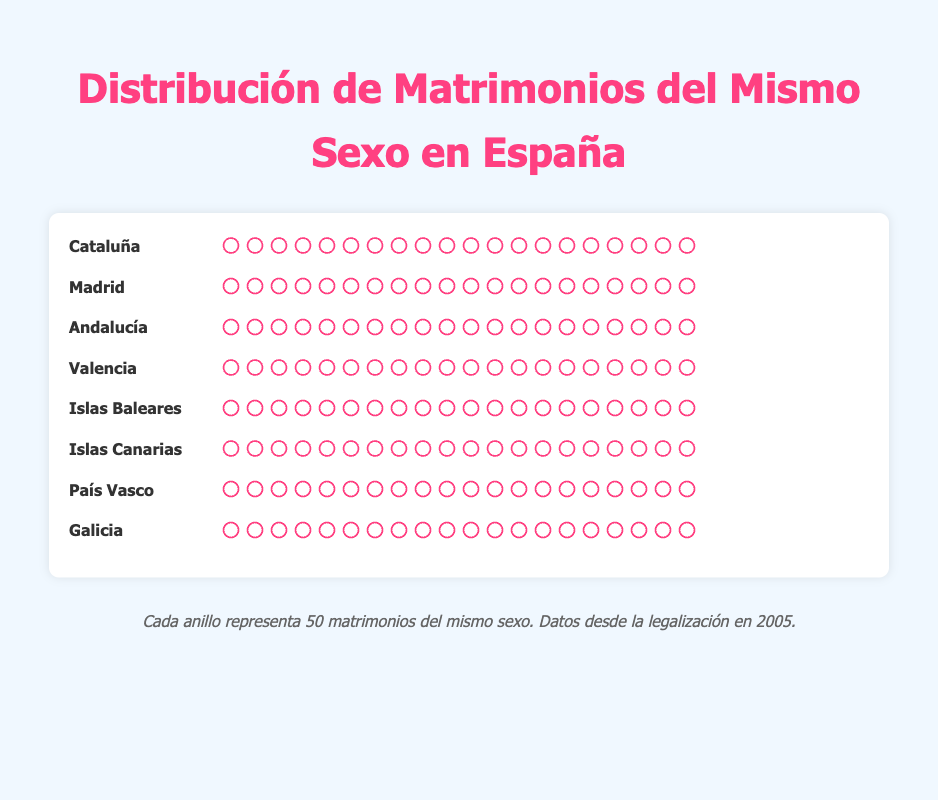Which region has the highest number of same-sex marriages? By looking at the figure, Catalonia has the most icons, which represent the number of marriages.
Answer: Catalonia How many same-sex marriages are there in Madrid? By counting the number of icons in the Madrid row, each representing 525 marriages, we see there are 20 icons. Multiplying 525 by 20 gives the total.
Answer: 10500 Which region has fewer same-sex marriages: Galicia or Basque Country? By comparing the number of icons in the rows for Galicia and Basque Country, Galicia has fewer icons.
Answer: Galicia What's the total number of same-sex marriages in Catalonia, Valencia, and Andalusia combined? To find the total, add the same-sex marriages in Catalonia (12000), Valencia (6500), and Andalusia (8000). 12000 + 6500 + 8000 = 26500.
Answer: 26500 How many more same-sex marriages are there in Balearic Islands compared to Canary Islands? Subtract the number of same-sex marriages in Canary Islands (3500) from those in Balearic Islands (4000). 4000 - 3500 = 500.
Answer: 500 Which region has approximately half the number of same-sex marriages as Catalonia? Compare the number of same-sex marriages in each region to half of Catalonia’s (12000/2 = 6000). Valencia has 6500 marriages, which is close to 6000.
Answer: Valencia How many regions have more than 5000 same-sex marriages? Count how many regions have same-sex marriages greater than 5000. Catalonia (12000), Madrid (10500), Andalusia (8000), and Valencia (6500) all qualify.
Answer: 4 regions Does Basque Country have more same-sex marriages than Galicia and Canary Islands combined? Calculate the combined number of same-sex marriages for Galicia (2500) and Canary Islands (3500), which is 6000. Compare it with Basque Country (3000). 3000 < 6000, so no.
Answer: No Which region has the least number of same-sex marriages? Look at the region with the fewest icons, which is Galicia.
Answer: Galicia What is the average number of same-sex marriages across all listed regions? Sum the same-sex marriages in all regions and divide by the number of regions. (12000 + 10500 + 8000 + 6500 + 4000 + 3500 + 3000 + 2500) / 8 = 42,000 / 8 = 5250.
Answer: 5250 